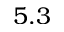<formula> <loc_0><loc_0><loc_500><loc_500>5 . 3</formula> 